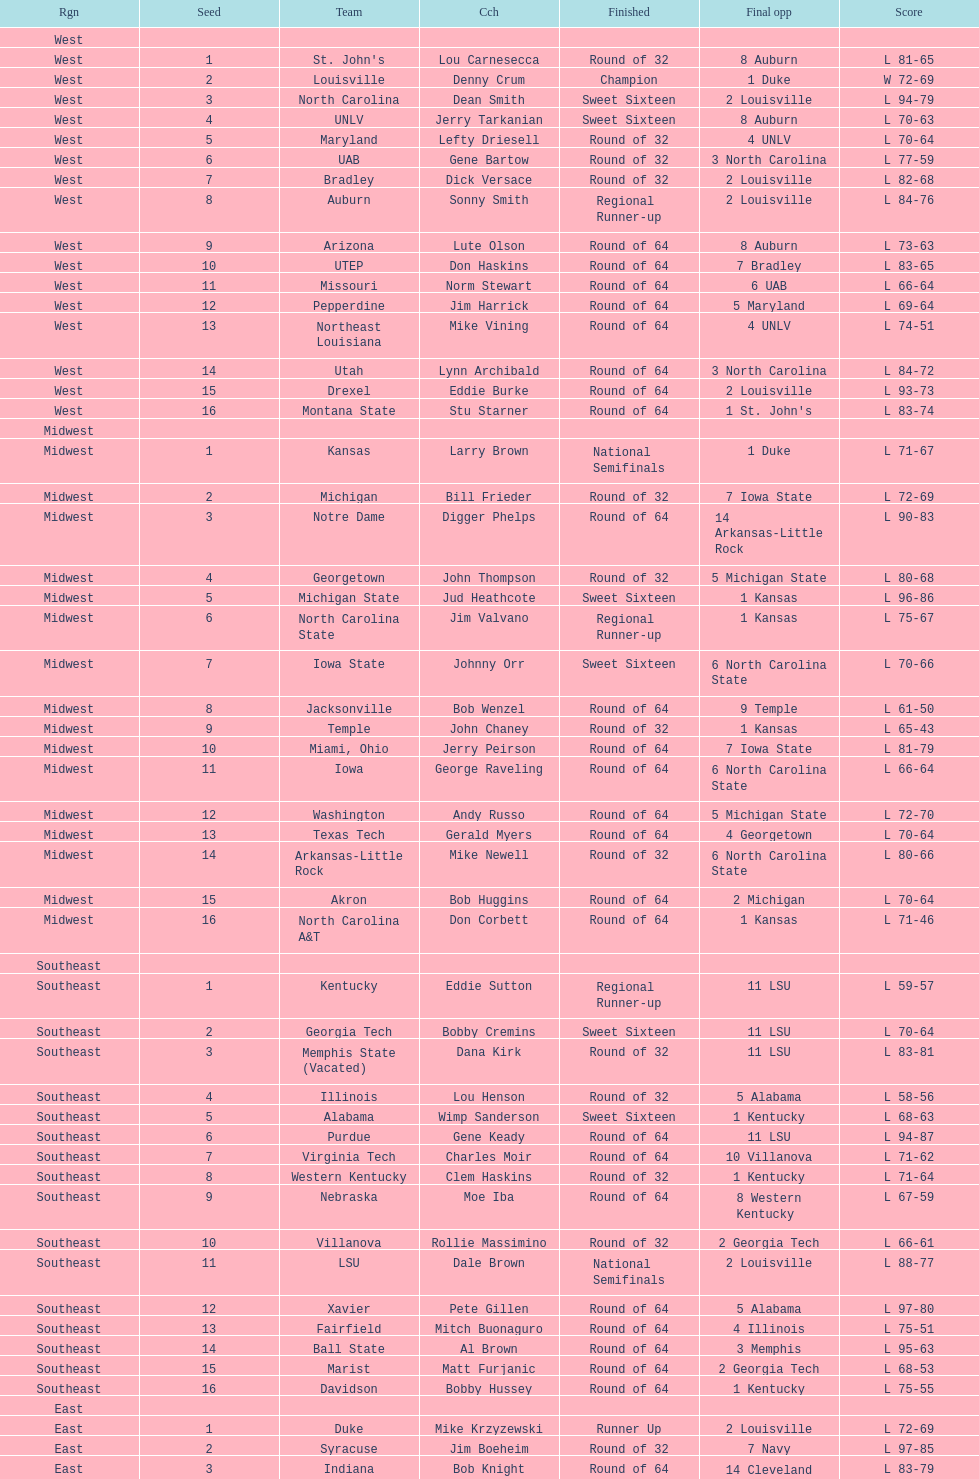How many number of teams played altogether? 64. I'm looking to parse the entire table for insights. Could you assist me with that? {'header': ['Rgn', 'Seed', 'Team', 'Cch', 'Finished', 'Final opp', 'Score'], 'rows': [['West', '', '', '', '', '', ''], ['West', '1', "St. John's", 'Lou Carnesecca', 'Round of 32', '8 Auburn', 'L 81-65'], ['West', '2', 'Louisville', 'Denny Crum', 'Champion', '1 Duke', 'W 72-69'], ['West', '3', 'North Carolina', 'Dean Smith', 'Sweet Sixteen', '2 Louisville', 'L 94-79'], ['West', '4', 'UNLV', 'Jerry Tarkanian', 'Sweet Sixteen', '8 Auburn', 'L 70-63'], ['West', '5', 'Maryland', 'Lefty Driesell', 'Round of 32', '4 UNLV', 'L 70-64'], ['West', '6', 'UAB', 'Gene Bartow', 'Round of 32', '3 North Carolina', 'L 77-59'], ['West', '7', 'Bradley', 'Dick Versace', 'Round of 32', '2 Louisville', 'L 82-68'], ['West', '8', 'Auburn', 'Sonny Smith', 'Regional Runner-up', '2 Louisville', 'L 84-76'], ['West', '9', 'Arizona', 'Lute Olson', 'Round of 64', '8 Auburn', 'L 73-63'], ['West', '10', 'UTEP', 'Don Haskins', 'Round of 64', '7 Bradley', 'L 83-65'], ['West', '11', 'Missouri', 'Norm Stewart', 'Round of 64', '6 UAB', 'L 66-64'], ['West', '12', 'Pepperdine', 'Jim Harrick', 'Round of 64', '5 Maryland', 'L 69-64'], ['West', '13', 'Northeast Louisiana', 'Mike Vining', 'Round of 64', '4 UNLV', 'L 74-51'], ['West', '14', 'Utah', 'Lynn Archibald', 'Round of 64', '3 North Carolina', 'L 84-72'], ['West', '15', 'Drexel', 'Eddie Burke', 'Round of 64', '2 Louisville', 'L 93-73'], ['West', '16', 'Montana State', 'Stu Starner', 'Round of 64', "1 St. John's", 'L 83-74'], ['Midwest', '', '', '', '', '', ''], ['Midwest', '1', 'Kansas', 'Larry Brown', 'National Semifinals', '1 Duke', 'L 71-67'], ['Midwest', '2', 'Michigan', 'Bill Frieder', 'Round of 32', '7 Iowa State', 'L 72-69'], ['Midwest', '3', 'Notre Dame', 'Digger Phelps', 'Round of 64', '14 Arkansas-Little Rock', 'L 90-83'], ['Midwest', '4', 'Georgetown', 'John Thompson', 'Round of 32', '5 Michigan State', 'L 80-68'], ['Midwest', '5', 'Michigan State', 'Jud Heathcote', 'Sweet Sixteen', '1 Kansas', 'L 96-86'], ['Midwest', '6', 'North Carolina State', 'Jim Valvano', 'Regional Runner-up', '1 Kansas', 'L 75-67'], ['Midwest', '7', 'Iowa State', 'Johnny Orr', 'Sweet Sixteen', '6 North Carolina State', 'L 70-66'], ['Midwest', '8', 'Jacksonville', 'Bob Wenzel', 'Round of 64', '9 Temple', 'L 61-50'], ['Midwest', '9', 'Temple', 'John Chaney', 'Round of 32', '1 Kansas', 'L 65-43'], ['Midwest', '10', 'Miami, Ohio', 'Jerry Peirson', 'Round of 64', '7 Iowa State', 'L 81-79'], ['Midwest', '11', 'Iowa', 'George Raveling', 'Round of 64', '6 North Carolina State', 'L 66-64'], ['Midwest', '12', 'Washington', 'Andy Russo', 'Round of 64', '5 Michigan State', 'L 72-70'], ['Midwest', '13', 'Texas Tech', 'Gerald Myers', 'Round of 64', '4 Georgetown', 'L 70-64'], ['Midwest', '14', 'Arkansas-Little Rock', 'Mike Newell', 'Round of 32', '6 North Carolina State', 'L 80-66'], ['Midwest', '15', 'Akron', 'Bob Huggins', 'Round of 64', '2 Michigan', 'L 70-64'], ['Midwest', '16', 'North Carolina A&T', 'Don Corbett', 'Round of 64', '1 Kansas', 'L 71-46'], ['Southeast', '', '', '', '', '', ''], ['Southeast', '1', 'Kentucky', 'Eddie Sutton', 'Regional Runner-up', '11 LSU', 'L 59-57'], ['Southeast', '2', 'Georgia Tech', 'Bobby Cremins', 'Sweet Sixteen', '11 LSU', 'L 70-64'], ['Southeast', '3', 'Memphis State (Vacated)', 'Dana Kirk', 'Round of 32', '11 LSU', 'L 83-81'], ['Southeast', '4', 'Illinois', 'Lou Henson', 'Round of 32', '5 Alabama', 'L 58-56'], ['Southeast', '5', 'Alabama', 'Wimp Sanderson', 'Sweet Sixteen', '1 Kentucky', 'L 68-63'], ['Southeast', '6', 'Purdue', 'Gene Keady', 'Round of 64', '11 LSU', 'L 94-87'], ['Southeast', '7', 'Virginia Tech', 'Charles Moir', 'Round of 64', '10 Villanova', 'L 71-62'], ['Southeast', '8', 'Western Kentucky', 'Clem Haskins', 'Round of 32', '1 Kentucky', 'L 71-64'], ['Southeast', '9', 'Nebraska', 'Moe Iba', 'Round of 64', '8 Western Kentucky', 'L 67-59'], ['Southeast', '10', 'Villanova', 'Rollie Massimino', 'Round of 32', '2 Georgia Tech', 'L 66-61'], ['Southeast', '11', 'LSU', 'Dale Brown', 'National Semifinals', '2 Louisville', 'L 88-77'], ['Southeast', '12', 'Xavier', 'Pete Gillen', 'Round of 64', '5 Alabama', 'L 97-80'], ['Southeast', '13', 'Fairfield', 'Mitch Buonaguro', 'Round of 64', '4 Illinois', 'L 75-51'], ['Southeast', '14', 'Ball State', 'Al Brown', 'Round of 64', '3 Memphis', 'L 95-63'], ['Southeast', '15', 'Marist', 'Matt Furjanic', 'Round of 64', '2 Georgia Tech', 'L 68-53'], ['Southeast', '16', 'Davidson', 'Bobby Hussey', 'Round of 64', '1 Kentucky', 'L 75-55'], ['East', '', '', '', '', '', ''], ['East', '1', 'Duke', 'Mike Krzyzewski', 'Runner Up', '2 Louisville', 'L 72-69'], ['East', '2', 'Syracuse', 'Jim Boeheim', 'Round of 32', '7 Navy', 'L 97-85'], ['East', '3', 'Indiana', 'Bob Knight', 'Round of 64', '14 Cleveland State', 'L 83-79'], ['East', '4', 'Oklahoma', 'Billy Tubbs', 'Round of 32', '12 DePaul', 'L 74-69'], ['East', '5', 'Virginia', 'Terry Holland', 'Round of 64', '12 DePaul', 'L 72-68'], ['East', '6', "Saint Joseph's", 'Jim Boyle', 'Round of 32', '14 Cleveland State', 'L 75-69'], ['East', '7', 'Navy', 'Paul Evans', 'Regional Runner-up', '1 Duke', 'L 71-50'], ['East', '8', 'Old Dominion', 'Tom Young', 'Round of 32', '1 Duke', 'L 89-61'], ['East', '9', 'West Virginia', 'Gale Catlett', 'Round of 64', '8 Old Dominion', 'L 72-64'], ['East', '10', 'Tulsa', 'J. D. Barnett', 'Round of 64', '7 Navy', 'L 87-68'], ['East', '11', 'Richmond', 'Dick Tarrant', 'Round of 64', "6 Saint Joseph's", 'L 60-59'], ['East', '12', 'DePaul', 'Joey Meyer', 'Sweet Sixteen', '1 Duke', 'L 74-67'], ['East', '13', 'Northeastern', 'Jim Calhoun', 'Round of 64', '4 Oklahoma', 'L 80-74'], ['East', '14', 'Cleveland State', 'Kevin Mackey', 'Sweet Sixteen', '7 Navy', 'L 71-70'], ['East', '15', 'Brown', 'Mike Cingiser', 'Round of 64', '2 Syracuse', 'L 101-52'], ['East', '16', 'Mississippi Valley State', 'Lafayette Stribling', 'Round of 64', '1 Duke', 'L 85-78']]} 